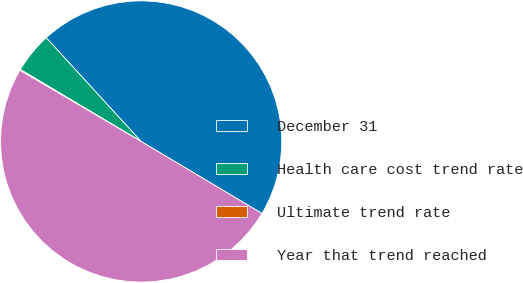<chart> <loc_0><loc_0><loc_500><loc_500><pie_chart><fcel>December 31<fcel>Health care cost trend rate<fcel>Ultimate trend rate<fcel>Year that trend reached<nl><fcel>45.35%<fcel>4.65%<fcel>0.11%<fcel>49.89%<nl></chart> 